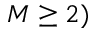<formula> <loc_0><loc_0><loc_500><loc_500>M \geq 2 )</formula> 